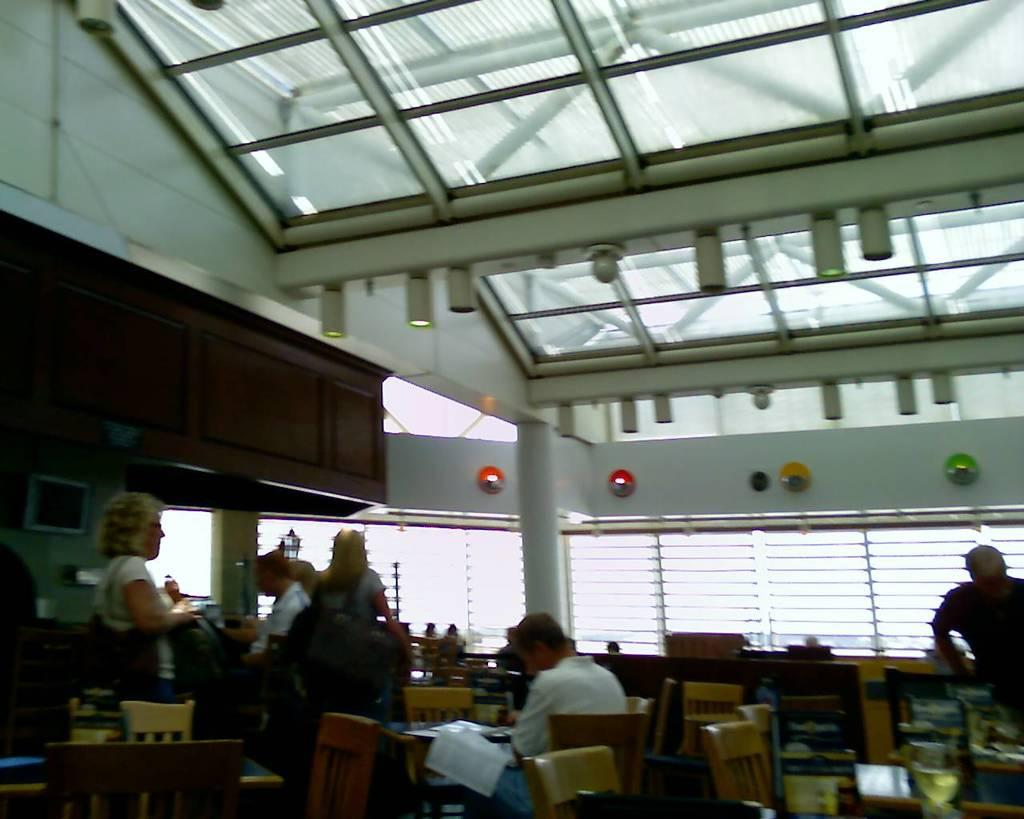How many people are in the image? There is a group of people in the image. What is the position of one of the people in the image? There is a person sitting on a chair. What type of furniture is present in the image? There are tables in the image. What is the status of one of the chairs in the image? There is an empty chair in the image. What can be seen in the background of the image? There is a pole and a window in the background of the image. How many bears are visible in the image? There are no bears present in the image. What type of leaf is being used as a prop by the person in the image? There is no leaf present in the image. 